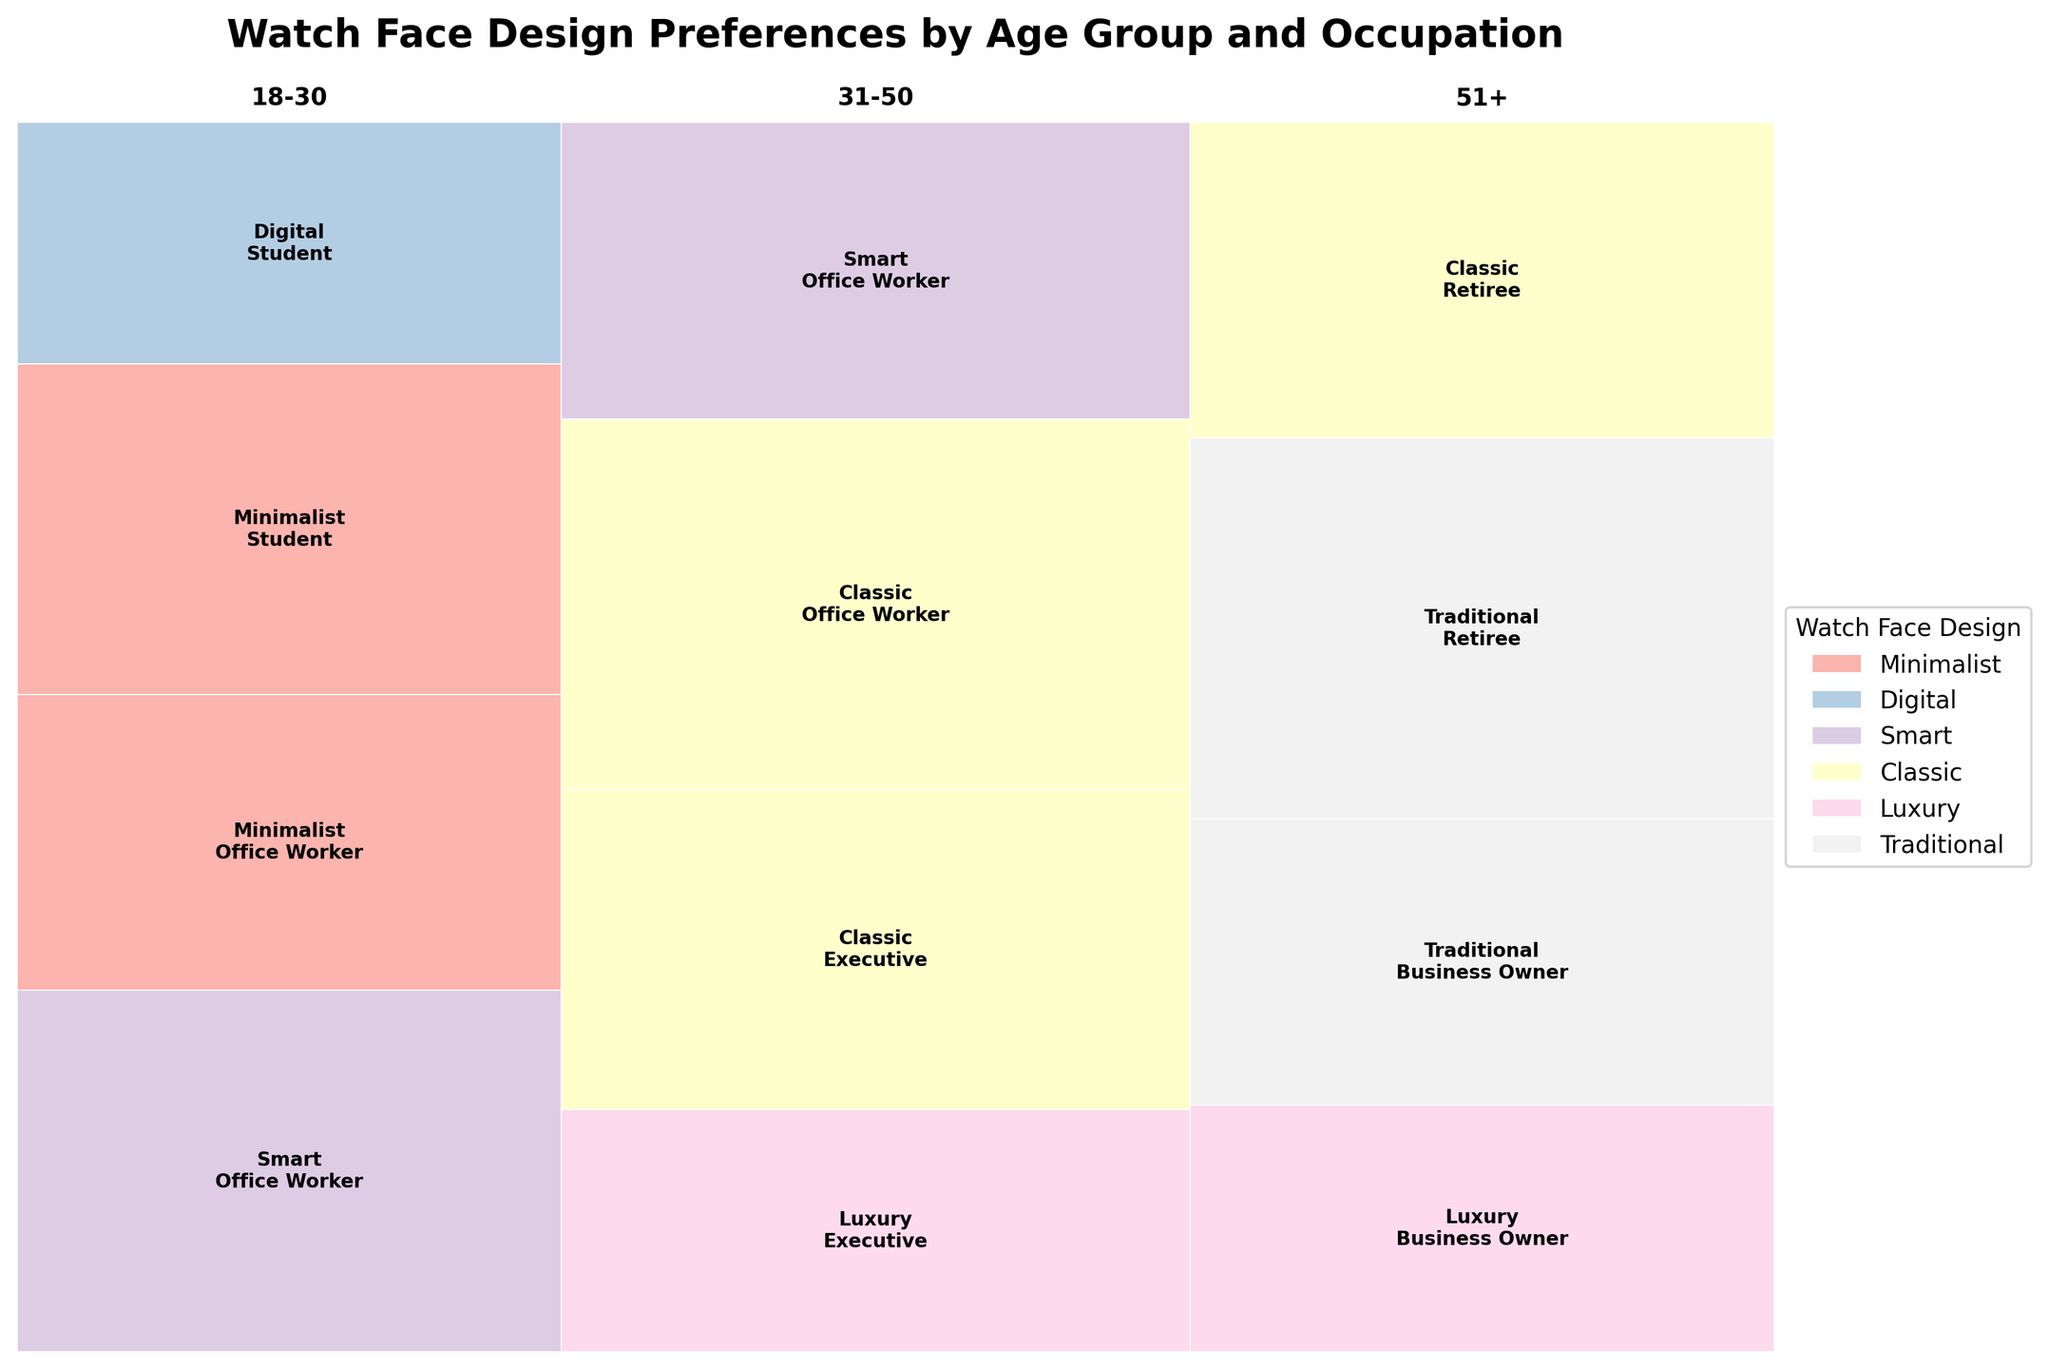What's the title of the mosaic plot? The title of the mosaic plot is located at the top of the figure. It is written in a larger and bold font.
Answer: Watch Face Design Preferences by Age Group and Occupation Which age group has the highest preference for the 'Minimalist' watch face design? Identify the rectangles with the label 'Minimalist' and compare the size of the corresponding segments for each age group. The age group associated with the largest area of the 'Minimalist' design will have the highest preference.
Answer: 18-30 In the 31-50 age group, which occupation prefers 'Classic' designs the most? For the 31-50 age group, locate the rectangles labeled 'Classic' and associated with different occupations. The occupation represented by the rectangle with the largest area indicates the highest preference for the 'Classic' design.
Answer: Office Worker List all watch face designs preferred by the '51+' age group. Examine the sections associated with the '51+' age group's rectangles and note down the watch face designs labeled within those sections. Ensure each design is counted only once.
Answer: Traditional, Classic, Luxury Which occupation in the '18-30' age group shows a higher preference for 'Smart' designs, Student or Office Worker? Within the '18-30' age group, compare the size of the rectangles labeled 'Smart' for both 'Student' and 'Office Worker'. The occupation with the larger area indicates a higher preference.
Answer: Office Worker What's the overall preference for the 'Luxury' watch face design for the '31-50' age group? Identify the rectangles labeled 'Luxury' within the '31-50' age group and sum their relative areas to determine the overall preference.
Answer: Both rectangles have about equal relative areas indicating a balanced preference Which age group shows more diversity in watch face design preferences? Compare the variety of labels within each age group's segment. The age group with more distinct designs listed indicates higher diversity in preferences.
Answer: 31-50 and 51+ What is the least preferred watch face design among 'Office Workers' in the 31-50 age group? Identify the sections associated with 'Office Workers' in the '31-50' age group and compare the areas of rectangles for each watch face design. The smallest area indicates the least preferred design.
Answer: Smart 